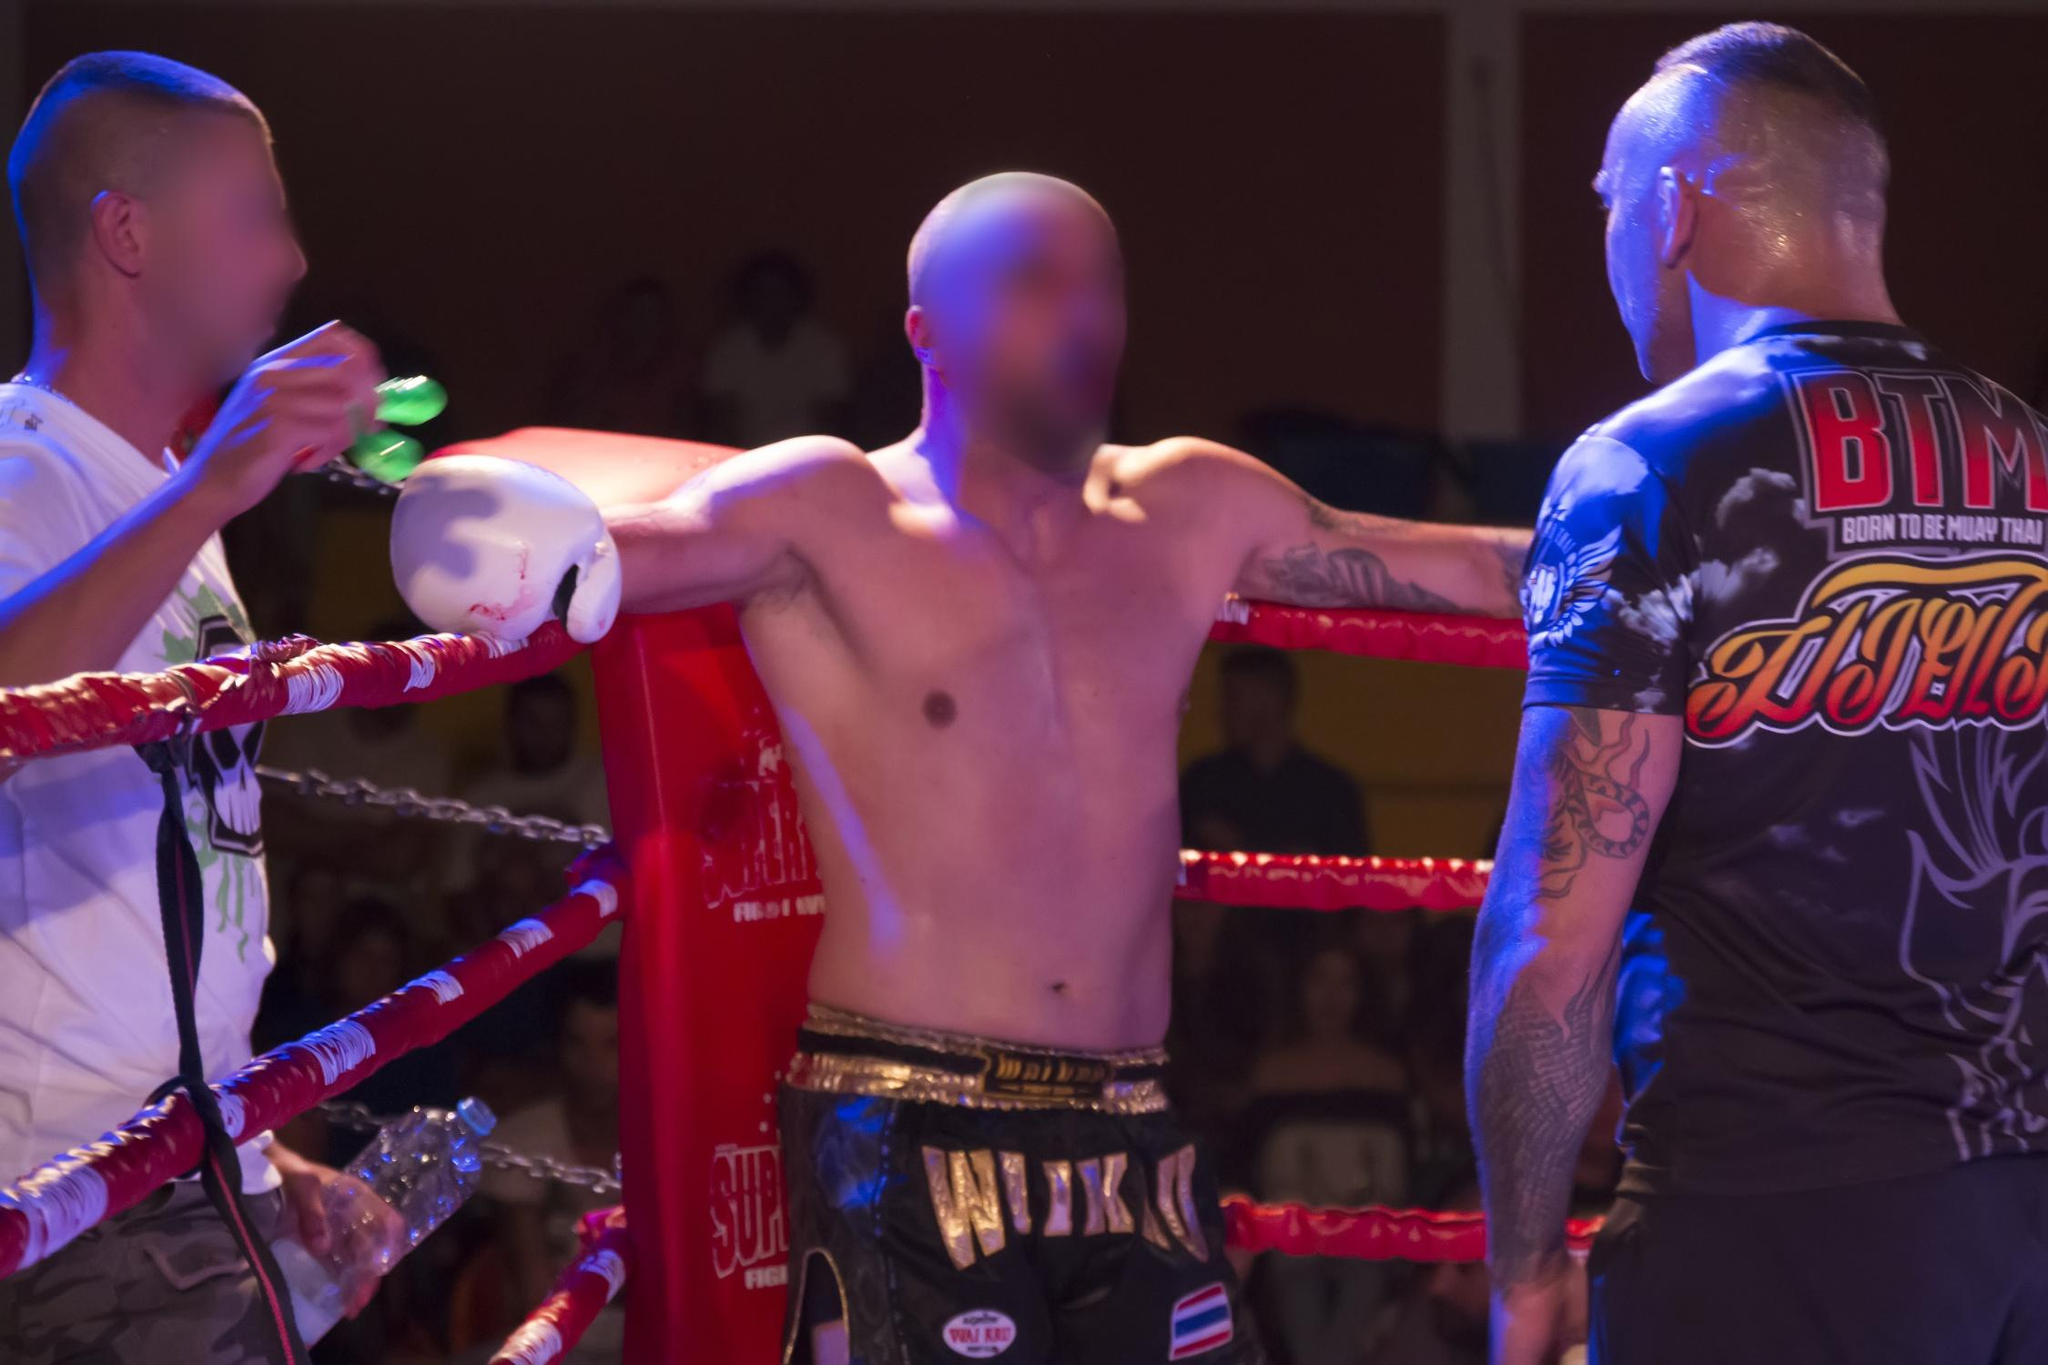Analyze the image in a comprehensive and detailed manner. The image portrays an intense moment during a boxing match viewed from the audience’s perspective, highlighting the communal and exhilarating experience of live sports. In focus is a boxer receiving attention in the corner of the ring, flanked by two coaches or assistants. The boxer, a central figure, stands with arms extended on the ropes, a posture reflecting either a break in the action or preparation for the next round. The figure to his right, possibly a coach, engages in a direct, possibly strategic discussion, evidenced by a bottle in hand, likely used for hydration or cooling. The blurred background with the audience illustrates the movement and energy typical of such sporting events, emphasizing the fast-paced and vibrant environment. The lighting casts a dramatic hue over the scene, focusing attention on the central figures and enhancing the emotional intensity of the spectacle. The attire and tattoos visible on the individuals suggest warrior-like readiness and personal histories, contributing to the story of endurance and battle embodied in the sport of boxing. 